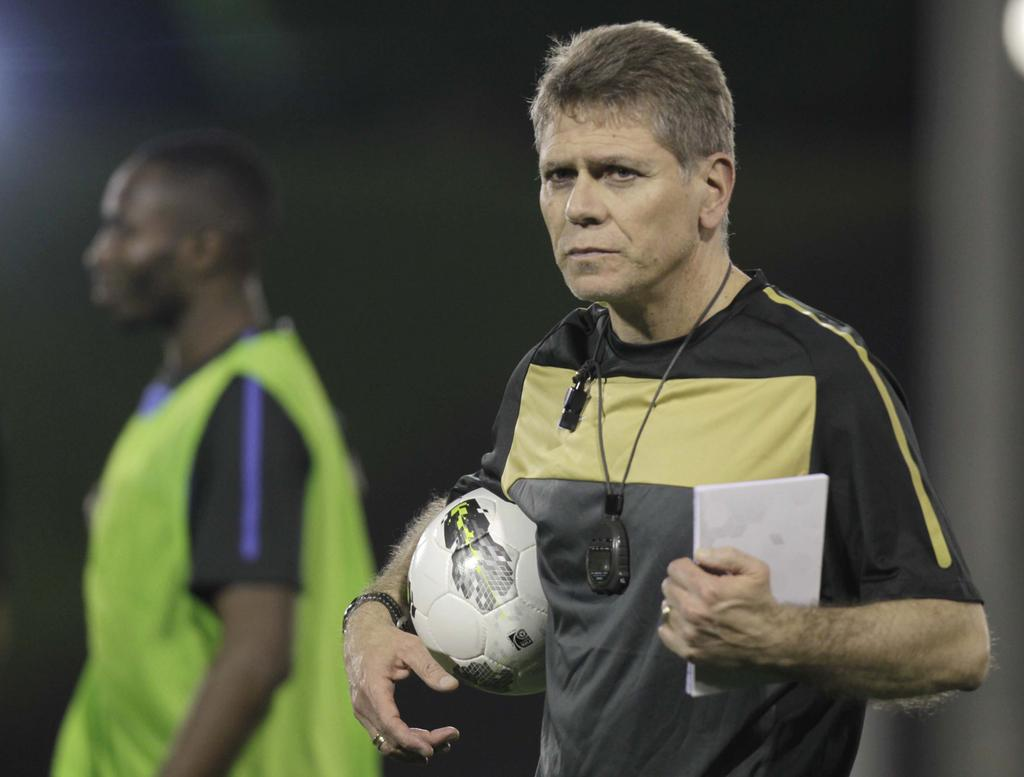What is the man in the image holding in one hand? The man is holding a ball in one hand. What is the man in the image holding in the other hand? The man is holding a book in the other hand. Can you describe the background of the image? There is another man in the background of the image. What type of cemetery can be seen in the image? There is no cemetery present in the image. How many cows are visible in the image? There are no cows present in the image. 